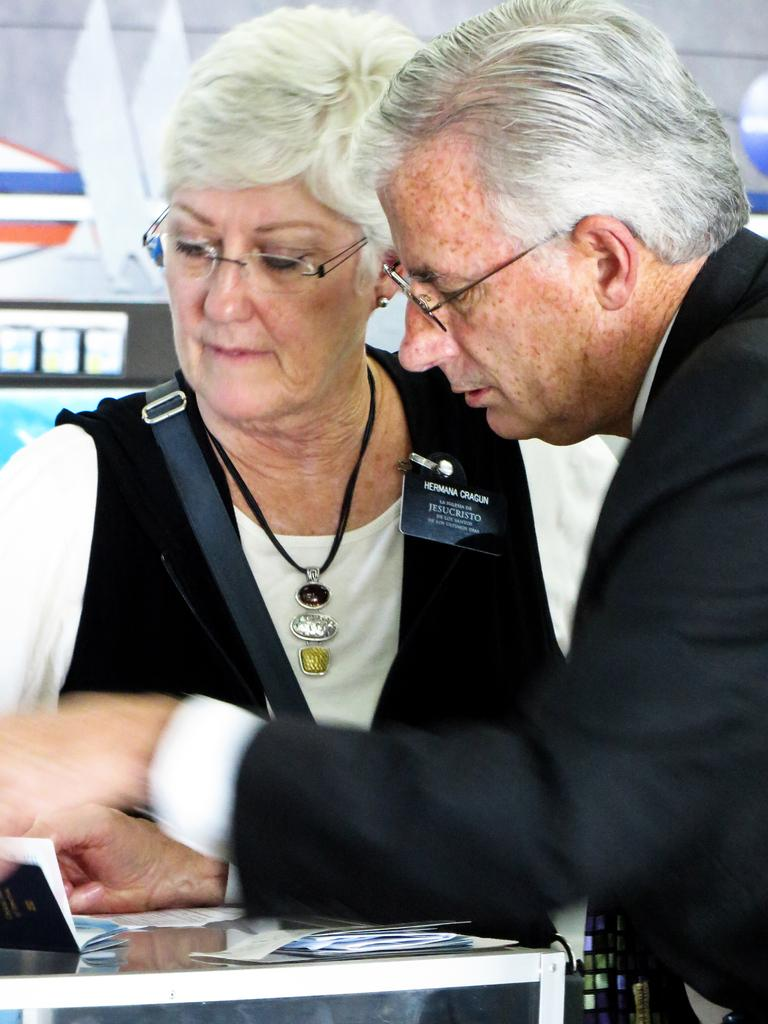How many people are in the foreground of the image? There are two persons in the foreground of the image. What can be seen on the table in the foreground? There are objects placed on a table in the foreground. What else is visible in the image besides the two persons and the table? There are many other objects visible in the background of the image. How many clovers can be seen growing on the table in the image? There are no clovers visible on the table in the image. What type of minister is present in the image? There is no minister present in the image. 